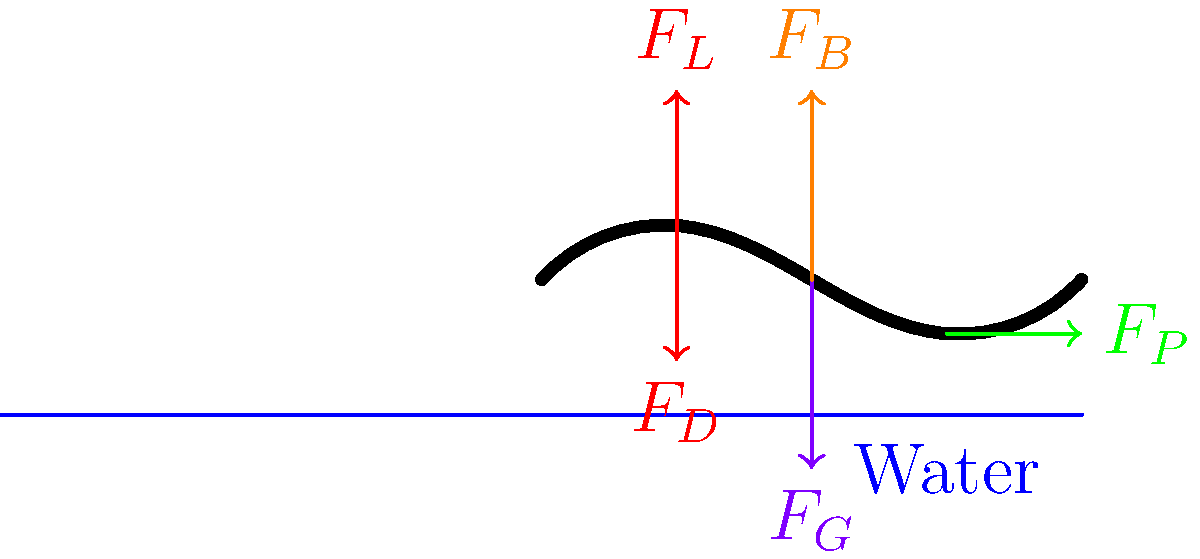In the butterfly stroke, which force represented in the diagram is primarily responsible for the swimmer's forward propulsion? Let's break down the forces acting on the swimmer during the butterfly stroke:

1. $F_L$: Lift force - Upward force generated by the swimmer's movement through the water.
2. $F_D$: Drag force - Resistance force opposing the swimmer's motion through the water.
3. $F_P$: Propulsive force - Force generated by the swimmer's arm and leg movements, pushing water backwards.
4. $F_G$: Gravitational force - Downward force due to the swimmer's weight.
5. $F_B$: Buoyant force - Upward force exerted by the water on the swimmer's body.

Among these forces, the propulsive force ($F_P$) is the one primarily responsible for the swimmer's forward motion. This force is generated by the swimmer's arm and leg movements, particularly during the powerful downward and backward sweep of the arms and the dolphin kick of the legs.

The propulsive force overcomes the drag force and pushes the swimmer forward through the water. While the other forces play important roles in the swimmer's overall dynamics, they do not directly contribute to forward propulsion.
Answer: $F_P$ (Propulsive force) 